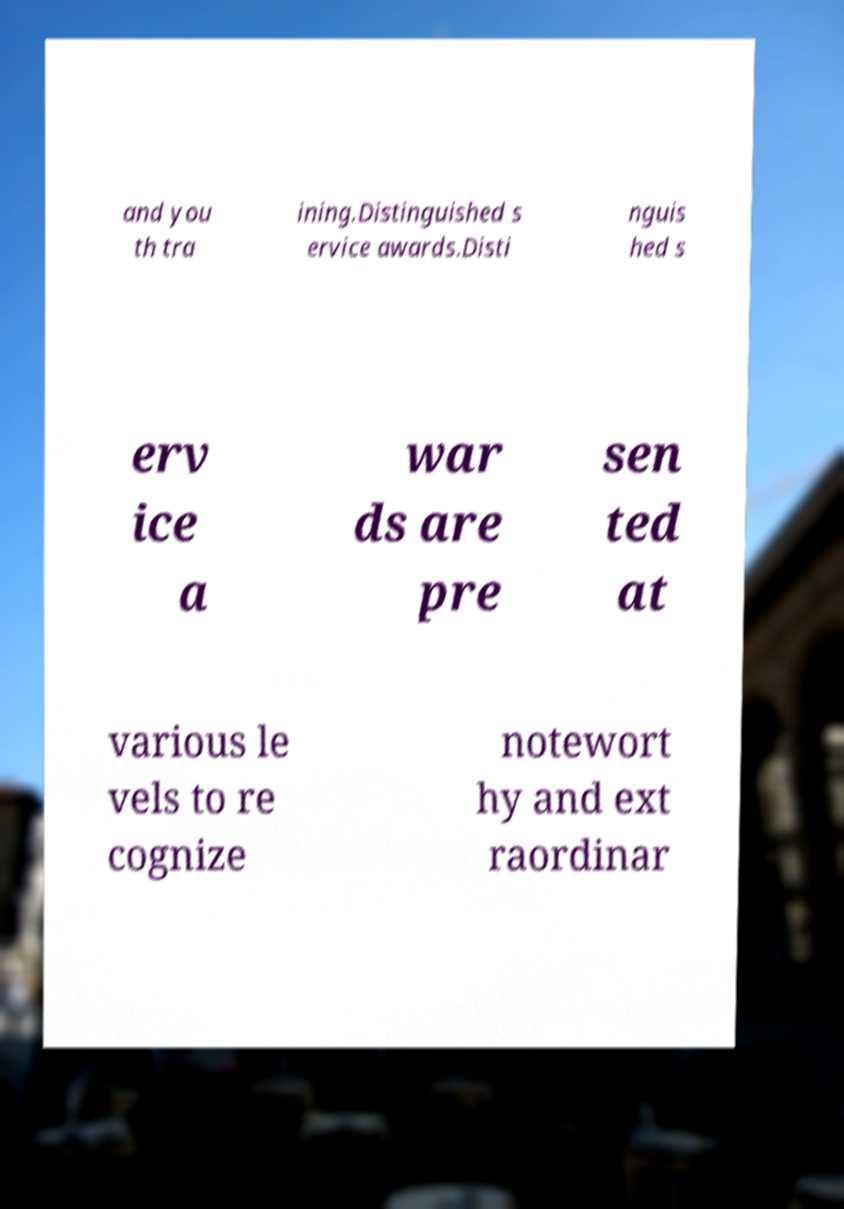What messages or text are displayed in this image? I need them in a readable, typed format. and you th tra ining.Distinguished s ervice awards.Disti nguis hed s erv ice a war ds are pre sen ted at various le vels to re cognize notewort hy and ext raordinar 